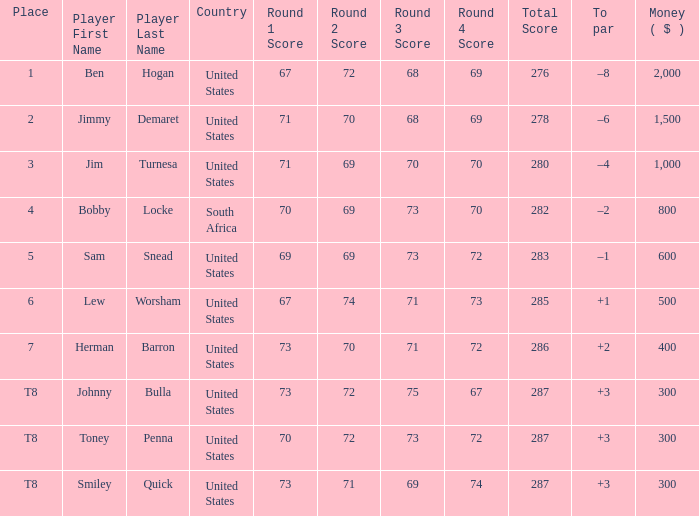What is the To par of the 4 Place Player? –2. 